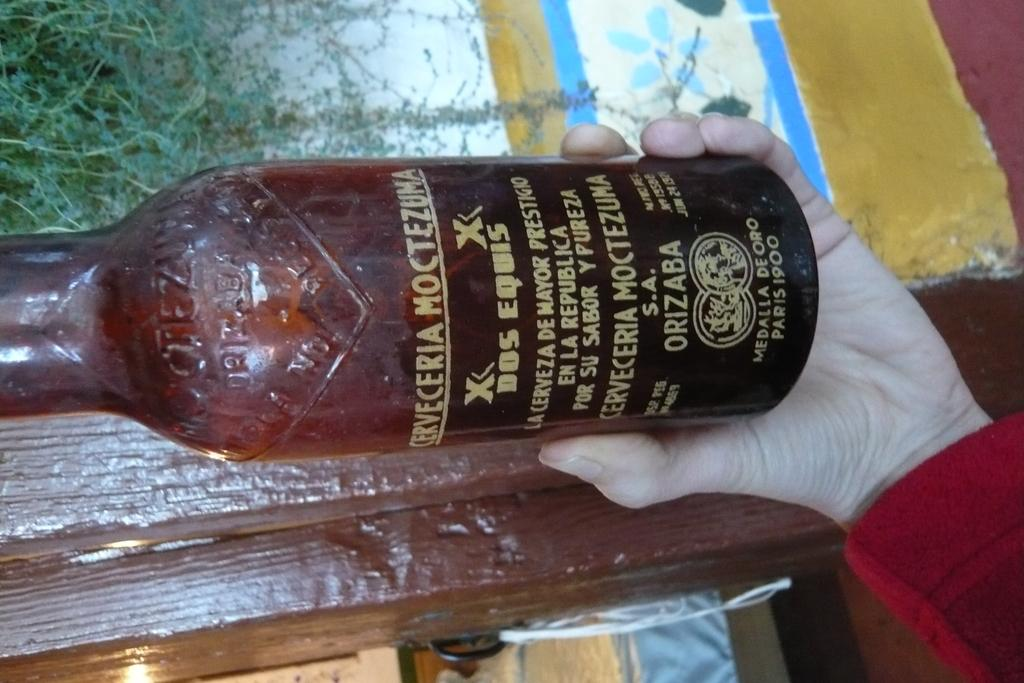What is being held by the person's hand in the image? There is a person's hand holding a bottle in the image. What can be seen in the distance behind the person? There are trees visible in the background of the image. What type of goose is being pushed by the person in the image? There is no goose present in the image, nor is anyone pushing a goose. 